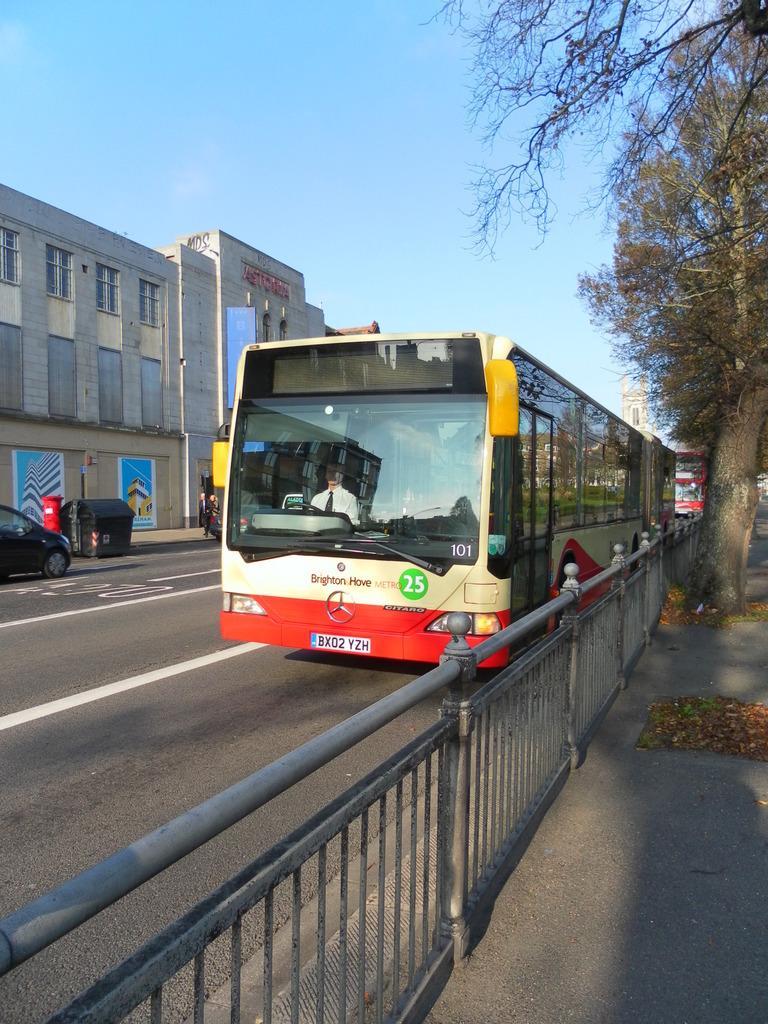Please provide a concise description of this image. In the foreground of this picture, there is a railing and a bus moving on the road. On the right side, there is a tree. In the background, there is a building, vehicles, dustbin and the sky. 